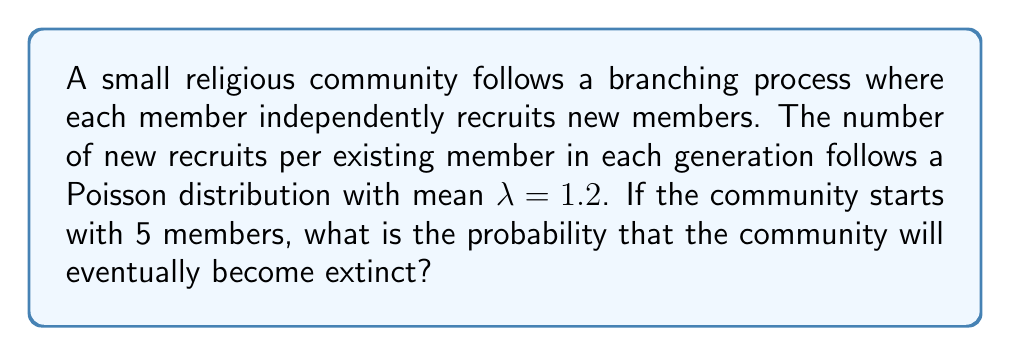Can you solve this math problem? To solve this problem, we'll use the theory of branching processes:

1) In a branching process, the extinction probability q satisfies the equation:
   $q = G(q)$, where G(s) is the probability generating function of the offspring distribution.

2) For a Poisson distribution with mean λ, the probability generating function is:
   $G(s) = e^{λ(s-1)}$

3) Therefore, we need to solve the equation:
   $q = e^{λ(q-1)}$

4) Substituting λ = 1.2:
   $q = e^{1.2(q-1)}$

5) This equation cannot be solved analytically, but we can solve it numerically.
   Using numerical methods (e.g., Newton-Raphson), we find:
   $q ≈ 0.7141$

6) This q is the probability of extinction starting from one member.

7) For a community starting with 5 members, the probability of extinction is:
   $q^5 ≈ (0.7141)^5 ≈ 0.1827$

Therefore, the probability that the community will eventually become extinct is approximately 0.1827 or 18.27%.
Answer: 0.1827 